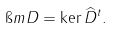<formula> <loc_0><loc_0><loc_500><loc_500>\i m D = \ker \widehat { D } ^ { t } .</formula> 